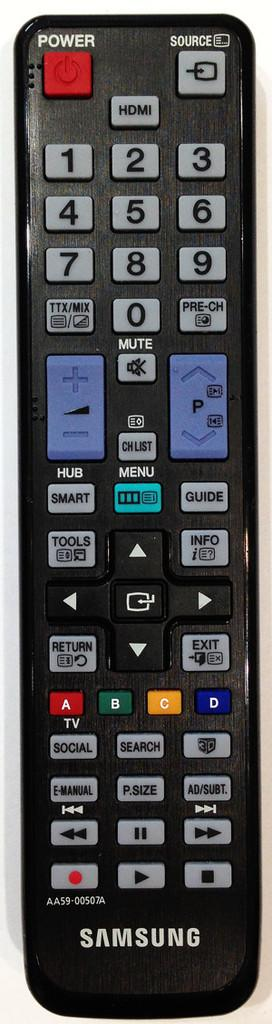<image>
Summarize the visual content of the image. a samsung remote control in black with many buttons 